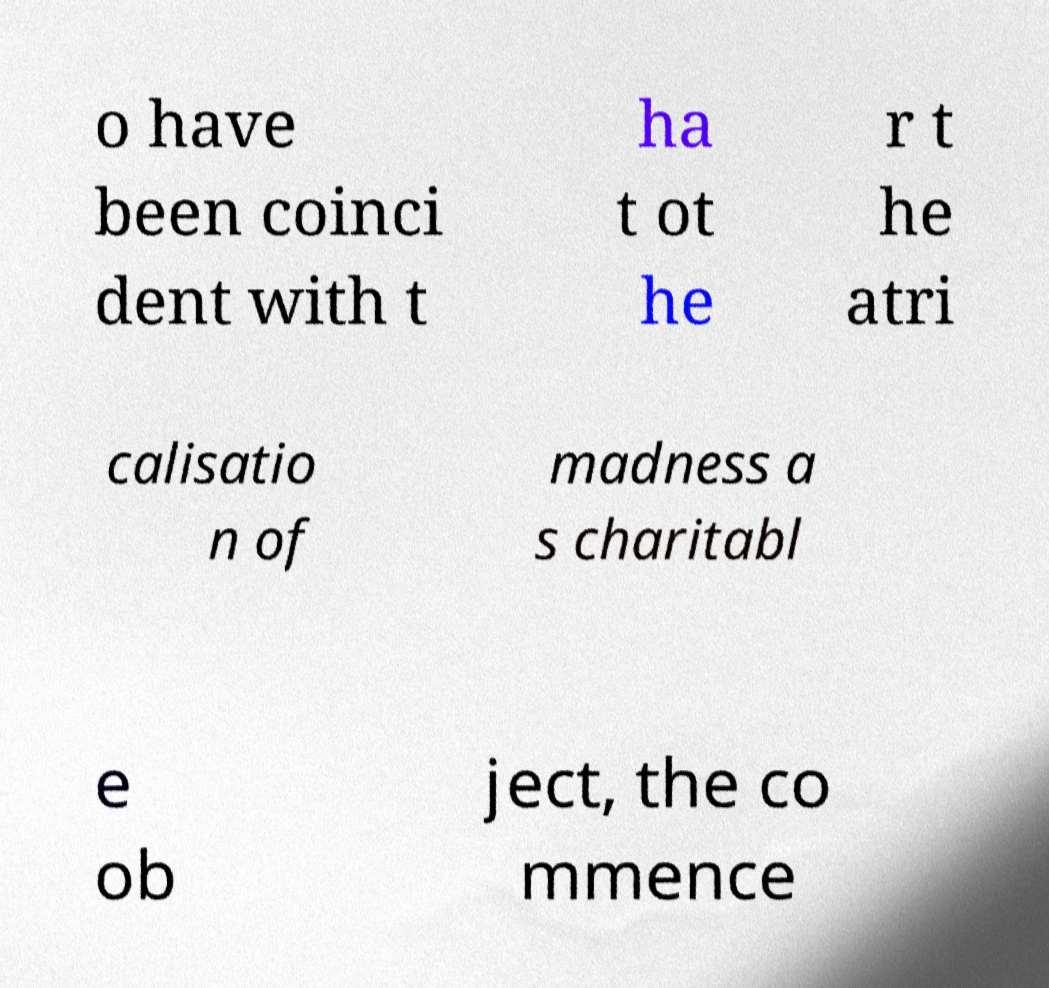What messages or text are displayed in this image? I need them in a readable, typed format. o have been coinci dent with t ha t ot he r t he atri calisatio n of madness a s charitabl e ob ject, the co mmence 